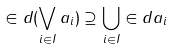Convert formula to latex. <formula><loc_0><loc_0><loc_500><loc_500>\in d ( \bigvee _ { i \in I } a _ { i } ) \supseteq \bigcup _ { i \in I } \in d a _ { i }</formula> 